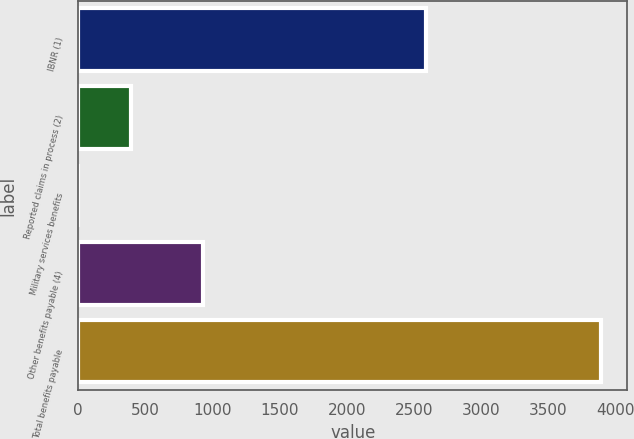Convert chart to OTSL. <chart><loc_0><loc_0><loc_500><loc_500><bar_chart><fcel>IBNR (1)<fcel>Reported claims in process (2)<fcel>Military services benefits<fcel>Other benefits payable (4)<fcel>Total benefits payable<nl><fcel>2586<fcel>390.78<fcel>1.64<fcel>926<fcel>3893<nl></chart> 